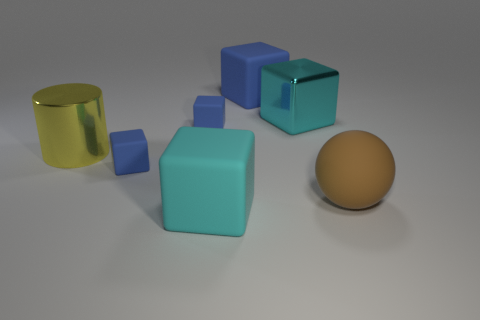Are there any reflective surfaces in the image? Yes, there are. The golden yellow object has a reflective metallic surface, and the light blue cubes also exhibit some degree of reflectiveness, though less pronounced than the golden object. 